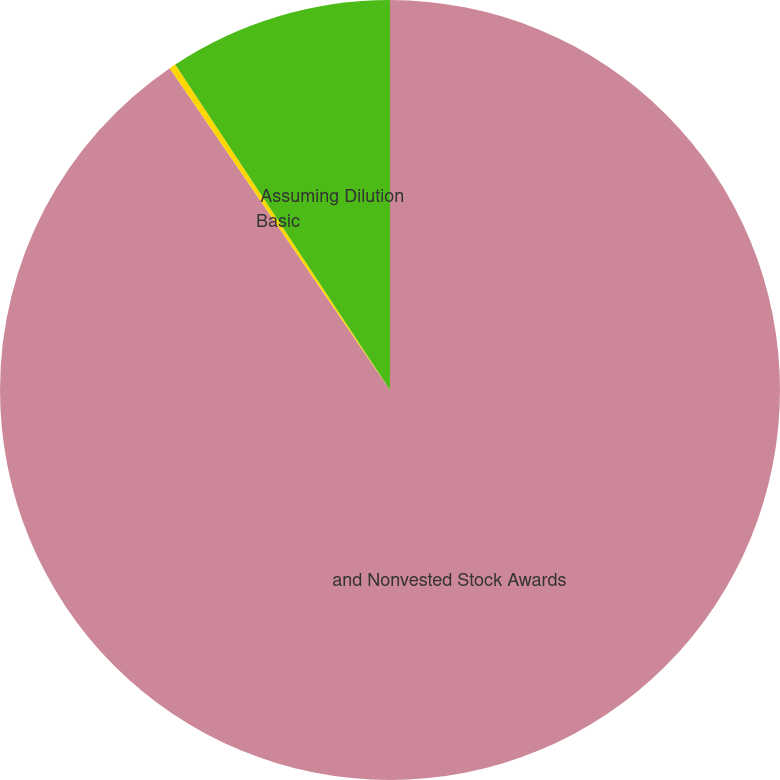Convert chart. <chart><loc_0><loc_0><loc_500><loc_500><pie_chart><fcel>and Nonvested Stock Awards<fcel>Basic<fcel>Assuming Dilution<nl><fcel>90.45%<fcel>0.27%<fcel>9.28%<nl></chart> 